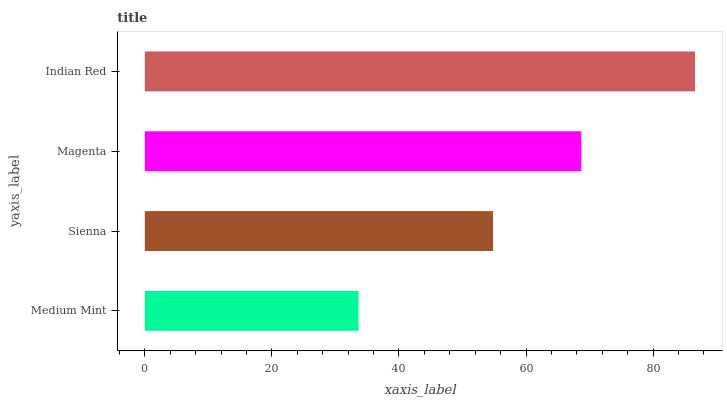Is Medium Mint the minimum?
Answer yes or no. Yes. Is Indian Red the maximum?
Answer yes or no. Yes. Is Sienna the minimum?
Answer yes or no. No. Is Sienna the maximum?
Answer yes or no. No. Is Sienna greater than Medium Mint?
Answer yes or no. Yes. Is Medium Mint less than Sienna?
Answer yes or no. Yes. Is Medium Mint greater than Sienna?
Answer yes or no. No. Is Sienna less than Medium Mint?
Answer yes or no. No. Is Magenta the high median?
Answer yes or no. Yes. Is Sienna the low median?
Answer yes or no. Yes. Is Indian Red the high median?
Answer yes or no. No. Is Indian Red the low median?
Answer yes or no. No. 